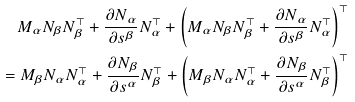Convert formula to latex. <formula><loc_0><loc_0><loc_500><loc_500>M _ { \alpha } N _ { \beta } N _ { \beta } ^ { \top } + \frac { \partial N _ { \alpha } } { \partial s ^ { \beta } } N _ { \alpha } ^ { \top } + \left ( M _ { \alpha } N _ { \beta } N _ { \beta } ^ { \top } + \frac { \partial N _ { \alpha } } { \partial s ^ { \beta } } N _ { \alpha } ^ { \top } \right ) ^ { \top } \\ = M _ { \beta } N _ { \alpha } N _ { \alpha } ^ { \top } + \frac { \partial N _ { \beta } } { \partial s ^ { \alpha } } N _ { \beta } ^ { \top } + \left ( M _ { \beta } N _ { \alpha } N _ { \alpha } ^ { \top } + \frac { \partial N _ { \beta } } { \partial s ^ { \alpha } } N _ { \beta } ^ { \top } \right ) ^ { \top }</formula> 